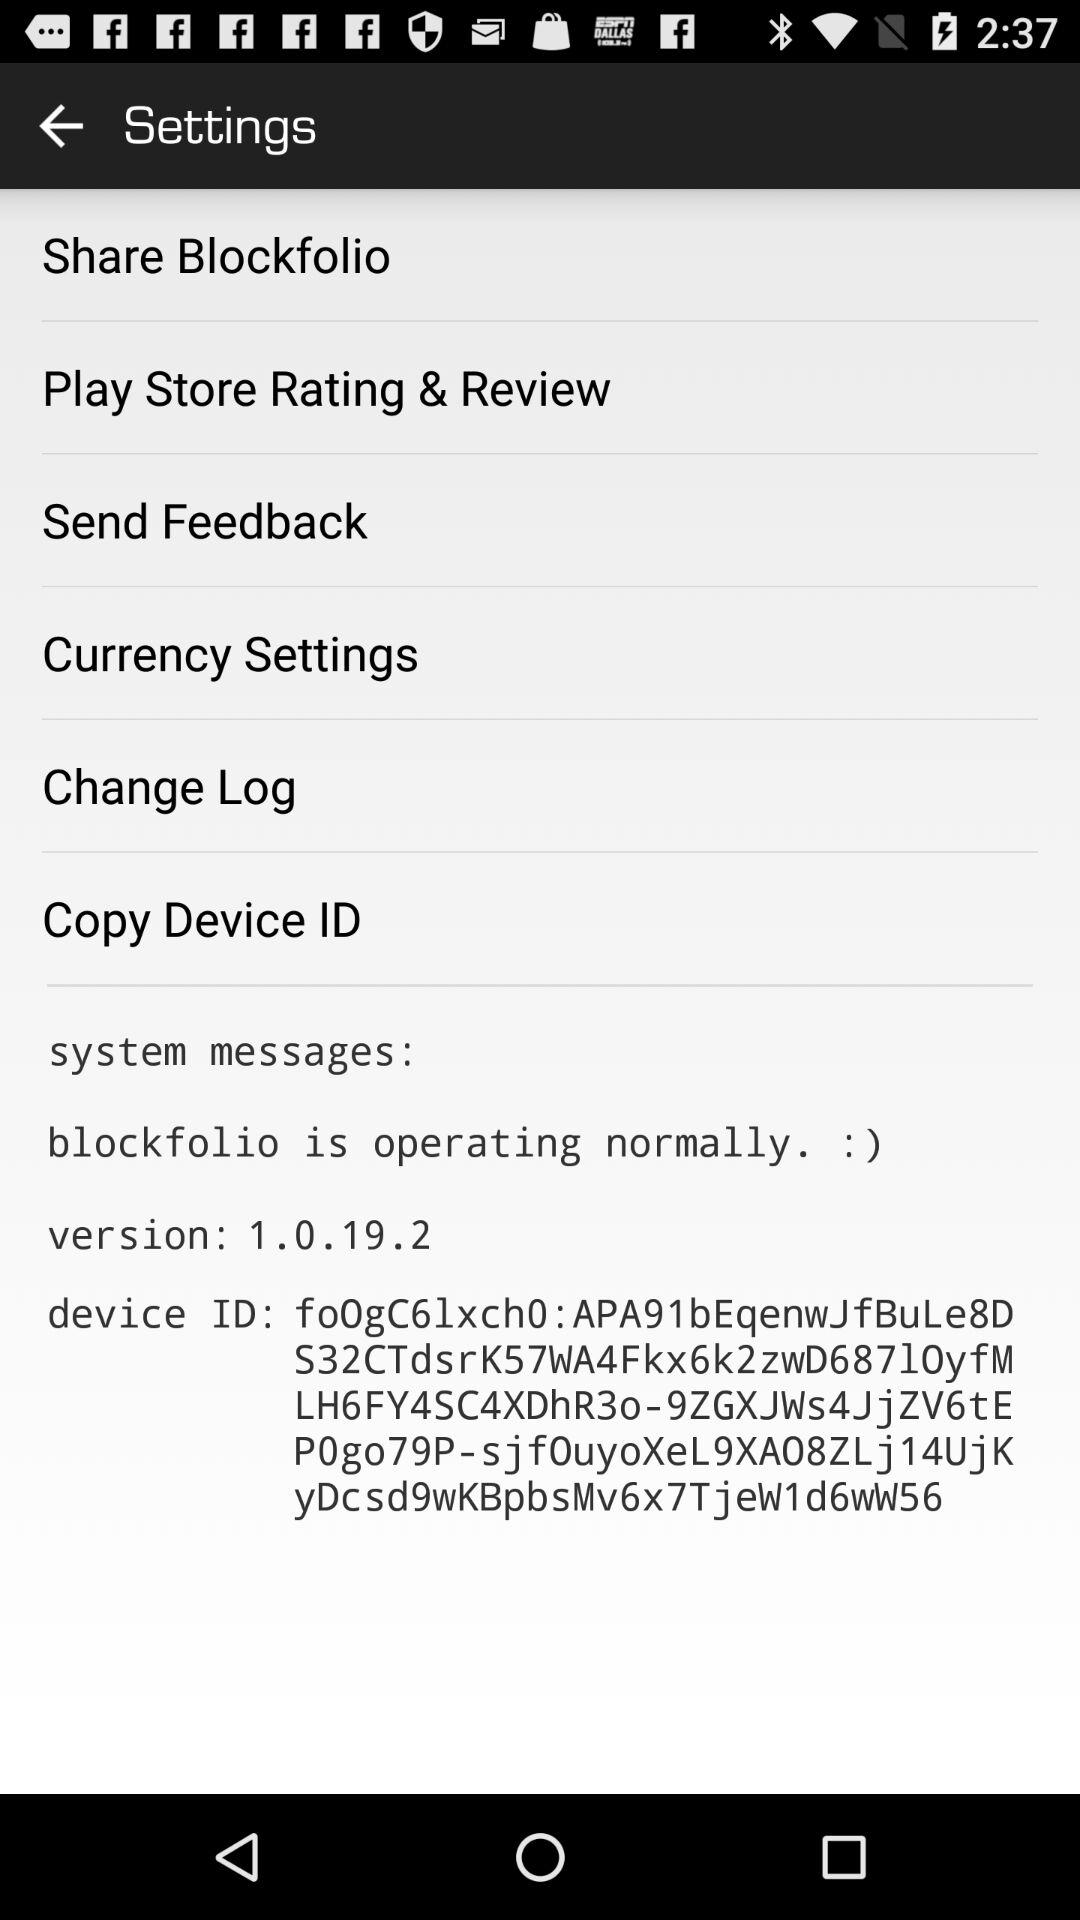How is the blockfolio operating? The blockfolio is operating normally. 